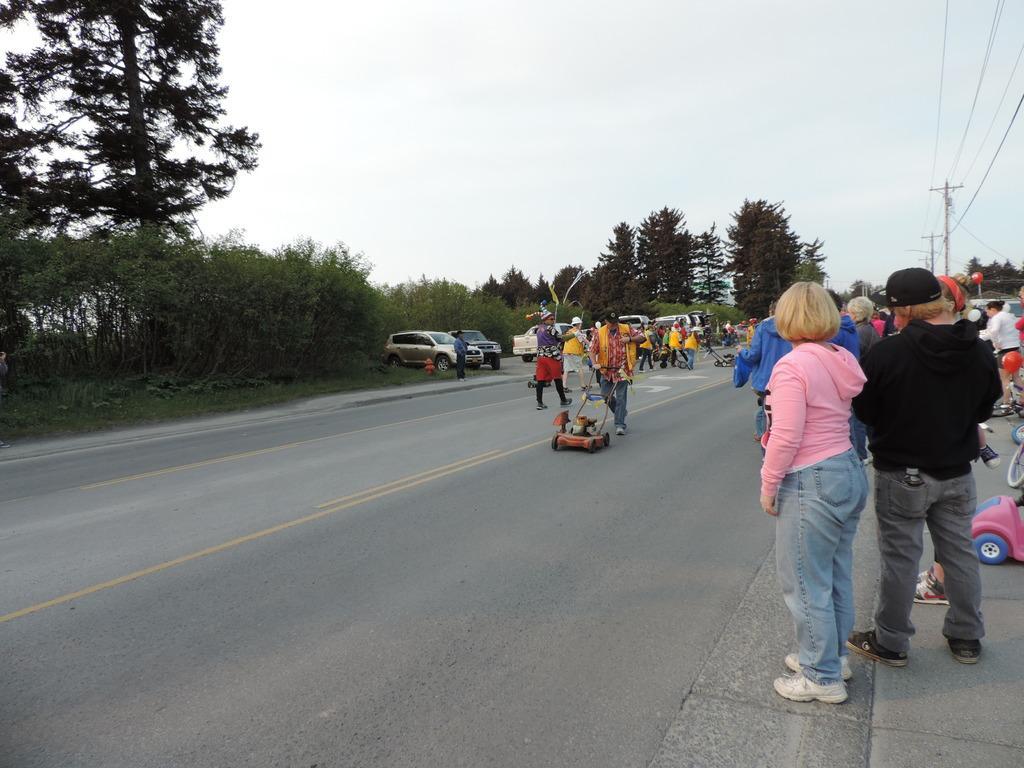Describe this image in one or two sentences. In this image there are a few people standing and walking on the road and there are few vehicles parked, there are few objects on the road. In the background there are trees, utility poles and the sky. 